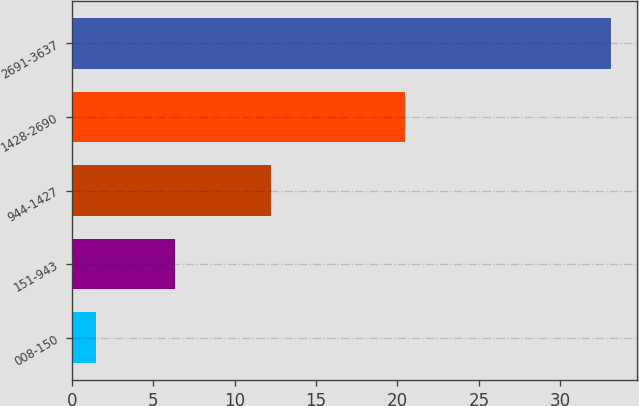Convert chart to OTSL. <chart><loc_0><loc_0><loc_500><loc_500><bar_chart><fcel>008-150<fcel>151-943<fcel>944-1427<fcel>1428-2690<fcel>2691-3637<nl><fcel>1.5<fcel>6.35<fcel>12.25<fcel>20.47<fcel>33.09<nl></chart> 